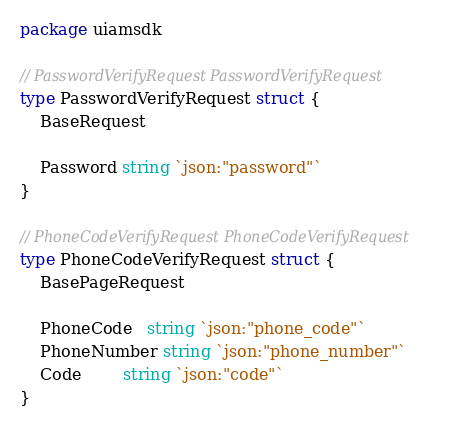Convert code to text. <code><loc_0><loc_0><loc_500><loc_500><_Go_>package uiamsdk

// PasswordVerifyRequest PasswordVerifyRequest
type PasswordVerifyRequest struct {
	BaseRequest

	Password string `json:"password"`
}

// PhoneCodeVerifyRequest PhoneCodeVerifyRequest
type PhoneCodeVerifyRequest struct {
	BasePageRequest

	PhoneCode   string `json:"phone_code"`
	PhoneNumber string `json:"phone_number"`
	Code        string `json:"code"`
}
</code> 